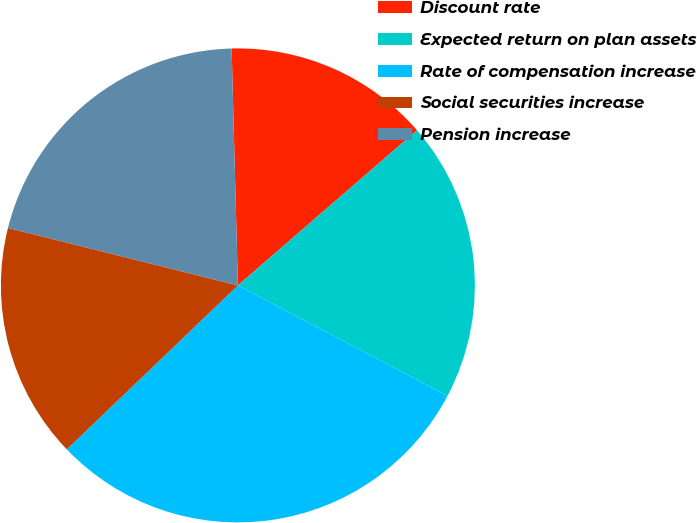Convert chart. <chart><loc_0><loc_0><loc_500><loc_500><pie_chart><fcel>Discount rate<fcel>Expected return on plan assets<fcel>Rate of compensation increase<fcel>Social securities increase<fcel>Pension increase<nl><fcel>14.06%<fcel>19.08%<fcel>30.12%<fcel>16.06%<fcel>20.68%<nl></chart> 